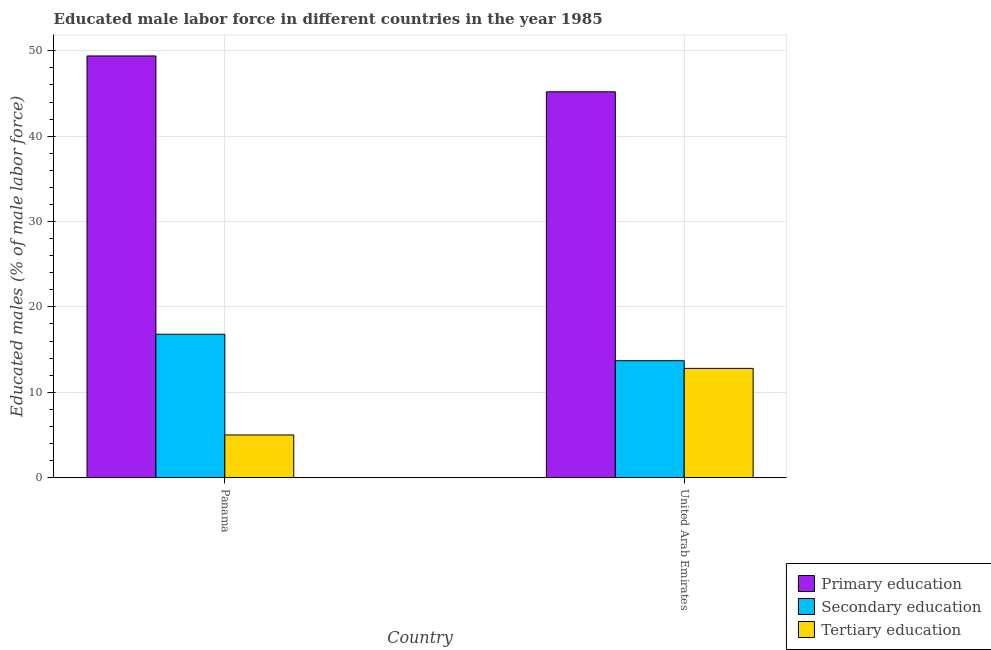Are the number of bars per tick equal to the number of legend labels?
Give a very brief answer. Yes. How many bars are there on the 1st tick from the left?
Provide a short and direct response. 3. How many bars are there on the 2nd tick from the right?
Offer a very short reply. 3. What is the label of the 1st group of bars from the left?
Your response must be concise. Panama. What is the percentage of male labor force who received secondary education in Panama?
Your response must be concise. 16.8. Across all countries, what is the maximum percentage of male labor force who received tertiary education?
Your response must be concise. 12.8. Across all countries, what is the minimum percentage of male labor force who received secondary education?
Your response must be concise. 13.7. In which country was the percentage of male labor force who received tertiary education maximum?
Provide a succinct answer. United Arab Emirates. In which country was the percentage of male labor force who received primary education minimum?
Offer a very short reply. United Arab Emirates. What is the total percentage of male labor force who received secondary education in the graph?
Offer a very short reply. 30.5. What is the difference between the percentage of male labor force who received tertiary education in Panama and that in United Arab Emirates?
Your answer should be very brief. -7.8. What is the difference between the percentage of male labor force who received tertiary education in United Arab Emirates and the percentage of male labor force who received primary education in Panama?
Offer a very short reply. -36.6. What is the average percentage of male labor force who received secondary education per country?
Offer a very short reply. 15.25. What is the difference between the percentage of male labor force who received primary education and percentage of male labor force who received tertiary education in Panama?
Make the answer very short. 44.4. What is the ratio of the percentage of male labor force who received primary education in Panama to that in United Arab Emirates?
Provide a succinct answer. 1.09. Is the percentage of male labor force who received secondary education in Panama less than that in United Arab Emirates?
Ensure brevity in your answer.  No. What does the 3rd bar from the left in Panama represents?
Your answer should be compact. Tertiary education. Is it the case that in every country, the sum of the percentage of male labor force who received primary education and percentage of male labor force who received secondary education is greater than the percentage of male labor force who received tertiary education?
Keep it short and to the point. Yes. How many bars are there?
Give a very brief answer. 6. Are all the bars in the graph horizontal?
Make the answer very short. No. Does the graph contain any zero values?
Provide a short and direct response. No. Where does the legend appear in the graph?
Your answer should be very brief. Bottom right. How are the legend labels stacked?
Keep it short and to the point. Vertical. What is the title of the graph?
Give a very brief answer. Educated male labor force in different countries in the year 1985. What is the label or title of the X-axis?
Offer a terse response. Country. What is the label or title of the Y-axis?
Your answer should be very brief. Educated males (% of male labor force). What is the Educated males (% of male labor force) in Primary education in Panama?
Your answer should be compact. 49.4. What is the Educated males (% of male labor force) of Secondary education in Panama?
Give a very brief answer. 16.8. What is the Educated males (% of male labor force) in Tertiary education in Panama?
Offer a terse response. 5. What is the Educated males (% of male labor force) of Primary education in United Arab Emirates?
Keep it short and to the point. 45.2. What is the Educated males (% of male labor force) of Secondary education in United Arab Emirates?
Ensure brevity in your answer.  13.7. What is the Educated males (% of male labor force) in Tertiary education in United Arab Emirates?
Give a very brief answer. 12.8. Across all countries, what is the maximum Educated males (% of male labor force) in Primary education?
Make the answer very short. 49.4. Across all countries, what is the maximum Educated males (% of male labor force) in Secondary education?
Offer a terse response. 16.8. Across all countries, what is the maximum Educated males (% of male labor force) of Tertiary education?
Offer a very short reply. 12.8. Across all countries, what is the minimum Educated males (% of male labor force) in Primary education?
Ensure brevity in your answer.  45.2. Across all countries, what is the minimum Educated males (% of male labor force) of Secondary education?
Ensure brevity in your answer.  13.7. Across all countries, what is the minimum Educated males (% of male labor force) of Tertiary education?
Your answer should be compact. 5. What is the total Educated males (% of male labor force) of Primary education in the graph?
Your answer should be compact. 94.6. What is the total Educated males (% of male labor force) of Secondary education in the graph?
Your answer should be very brief. 30.5. What is the difference between the Educated males (% of male labor force) of Tertiary education in Panama and that in United Arab Emirates?
Your answer should be compact. -7.8. What is the difference between the Educated males (% of male labor force) in Primary education in Panama and the Educated males (% of male labor force) in Secondary education in United Arab Emirates?
Offer a terse response. 35.7. What is the difference between the Educated males (% of male labor force) in Primary education in Panama and the Educated males (% of male labor force) in Tertiary education in United Arab Emirates?
Make the answer very short. 36.6. What is the difference between the Educated males (% of male labor force) of Secondary education in Panama and the Educated males (% of male labor force) of Tertiary education in United Arab Emirates?
Your answer should be very brief. 4. What is the average Educated males (% of male labor force) in Primary education per country?
Your response must be concise. 47.3. What is the average Educated males (% of male labor force) in Secondary education per country?
Offer a terse response. 15.25. What is the difference between the Educated males (% of male labor force) of Primary education and Educated males (% of male labor force) of Secondary education in Panama?
Provide a short and direct response. 32.6. What is the difference between the Educated males (% of male labor force) in Primary education and Educated males (% of male labor force) in Tertiary education in Panama?
Keep it short and to the point. 44.4. What is the difference between the Educated males (% of male labor force) in Secondary education and Educated males (% of male labor force) in Tertiary education in Panama?
Give a very brief answer. 11.8. What is the difference between the Educated males (% of male labor force) in Primary education and Educated males (% of male labor force) in Secondary education in United Arab Emirates?
Ensure brevity in your answer.  31.5. What is the difference between the Educated males (% of male labor force) of Primary education and Educated males (% of male labor force) of Tertiary education in United Arab Emirates?
Give a very brief answer. 32.4. What is the difference between the Educated males (% of male labor force) in Secondary education and Educated males (% of male labor force) in Tertiary education in United Arab Emirates?
Provide a succinct answer. 0.9. What is the ratio of the Educated males (% of male labor force) of Primary education in Panama to that in United Arab Emirates?
Offer a terse response. 1.09. What is the ratio of the Educated males (% of male labor force) in Secondary education in Panama to that in United Arab Emirates?
Ensure brevity in your answer.  1.23. What is the ratio of the Educated males (% of male labor force) of Tertiary education in Panama to that in United Arab Emirates?
Provide a short and direct response. 0.39. What is the difference between the highest and the second highest Educated males (% of male labor force) of Primary education?
Make the answer very short. 4.2. What is the difference between the highest and the second highest Educated males (% of male labor force) of Tertiary education?
Ensure brevity in your answer.  7.8. What is the difference between the highest and the lowest Educated males (% of male labor force) in Secondary education?
Provide a short and direct response. 3.1. 